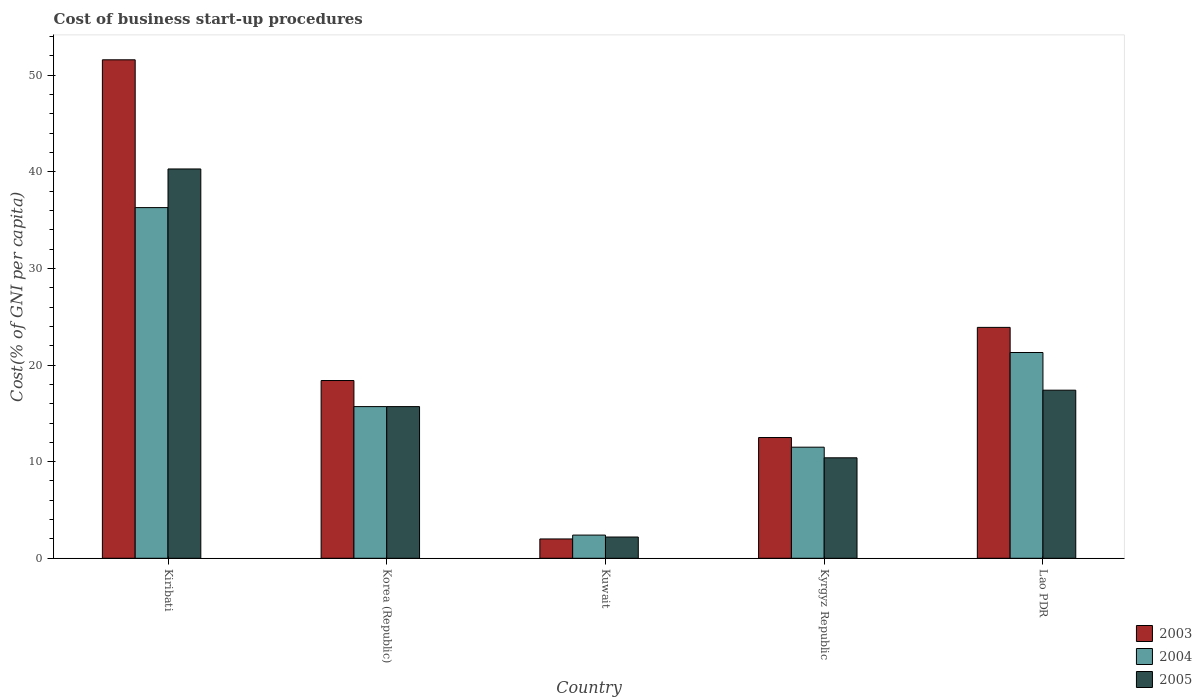How many different coloured bars are there?
Make the answer very short. 3. How many groups of bars are there?
Provide a short and direct response. 5. Are the number of bars per tick equal to the number of legend labels?
Keep it short and to the point. Yes. Are the number of bars on each tick of the X-axis equal?
Provide a succinct answer. Yes. How many bars are there on the 3rd tick from the right?
Your answer should be compact. 3. What is the label of the 4th group of bars from the left?
Your answer should be very brief. Kyrgyz Republic. In how many cases, is the number of bars for a given country not equal to the number of legend labels?
Your response must be concise. 0. What is the cost of business start-up procedures in 2004 in Korea (Republic)?
Make the answer very short. 15.7. Across all countries, what is the maximum cost of business start-up procedures in 2004?
Your response must be concise. 36.3. Across all countries, what is the minimum cost of business start-up procedures in 2003?
Provide a short and direct response. 2. In which country was the cost of business start-up procedures in 2003 maximum?
Keep it short and to the point. Kiribati. In which country was the cost of business start-up procedures in 2003 minimum?
Provide a short and direct response. Kuwait. What is the total cost of business start-up procedures in 2003 in the graph?
Give a very brief answer. 108.4. What is the difference between the cost of business start-up procedures in 2004 in Kuwait and that in Lao PDR?
Ensure brevity in your answer.  -18.9. What is the difference between the cost of business start-up procedures in 2005 in Kiribati and the cost of business start-up procedures in 2003 in Korea (Republic)?
Your response must be concise. 21.9. What is the average cost of business start-up procedures in 2003 per country?
Give a very brief answer. 21.68. What is the difference between the cost of business start-up procedures of/in 2003 and cost of business start-up procedures of/in 2004 in Kuwait?
Your answer should be compact. -0.4. What is the ratio of the cost of business start-up procedures in 2004 in Kyrgyz Republic to that in Lao PDR?
Ensure brevity in your answer.  0.54. Is the cost of business start-up procedures in 2005 in Kyrgyz Republic less than that in Lao PDR?
Your response must be concise. Yes. Is the difference between the cost of business start-up procedures in 2003 in Kiribati and Lao PDR greater than the difference between the cost of business start-up procedures in 2004 in Kiribati and Lao PDR?
Provide a succinct answer. Yes. What is the difference between the highest and the second highest cost of business start-up procedures in 2005?
Ensure brevity in your answer.  22.9. What is the difference between the highest and the lowest cost of business start-up procedures in 2004?
Provide a short and direct response. 33.9. How many bars are there?
Make the answer very short. 15. What is the difference between two consecutive major ticks on the Y-axis?
Provide a short and direct response. 10. Are the values on the major ticks of Y-axis written in scientific E-notation?
Offer a very short reply. No. Where does the legend appear in the graph?
Provide a succinct answer. Bottom right. How many legend labels are there?
Keep it short and to the point. 3. What is the title of the graph?
Ensure brevity in your answer.  Cost of business start-up procedures. What is the label or title of the X-axis?
Ensure brevity in your answer.  Country. What is the label or title of the Y-axis?
Offer a terse response. Cost(% of GNI per capita). What is the Cost(% of GNI per capita) of 2003 in Kiribati?
Your answer should be very brief. 51.6. What is the Cost(% of GNI per capita) in 2004 in Kiribati?
Give a very brief answer. 36.3. What is the Cost(% of GNI per capita) in 2005 in Kiribati?
Offer a very short reply. 40.3. What is the Cost(% of GNI per capita) in 2003 in Kuwait?
Provide a short and direct response. 2. What is the Cost(% of GNI per capita) of 2005 in Kuwait?
Offer a very short reply. 2.2. What is the Cost(% of GNI per capita) in 2003 in Lao PDR?
Give a very brief answer. 23.9. What is the Cost(% of GNI per capita) of 2004 in Lao PDR?
Provide a short and direct response. 21.3. What is the Cost(% of GNI per capita) of 2005 in Lao PDR?
Your answer should be very brief. 17.4. Across all countries, what is the maximum Cost(% of GNI per capita) in 2003?
Keep it short and to the point. 51.6. Across all countries, what is the maximum Cost(% of GNI per capita) of 2004?
Ensure brevity in your answer.  36.3. Across all countries, what is the maximum Cost(% of GNI per capita) in 2005?
Your answer should be compact. 40.3. Across all countries, what is the minimum Cost(% of GNI per capita) of 2003?
Make the answer very short. 2. Across all countries, what is the minimum Cost(% of GNI per capita) of 2004?
Offer a very short reply. 2.4. What is the total Cost(% of GNI per capita) of 2003 in the graph?
Provide a succinct answer. 108.4. What is the total Cost(% of GNI per capita) of 2004 in the graph?
Offer a terse response. 87.2. What is the difference between the Cost(% of GNI per capita) in 2003 in Kiribati and that in Korea (Republic)?
Make the answer very short. 33.2. What is the difference between the Cost(% of GNI per capita) of 2004 in Kiribati and that in Korea (Republic)?
Provide a succinct answer. 20.6. What is the difference between the Cost(% of GNI per capita) in 2005 in Kiribati and that in Korea (Republic)?
Your response must be concise. 24.6. What is the difference between the Cost(% of GNI per capita) of 2003 in Kiribati and that in Kuwait?
Your answer should be compact. 49.6. What is the difference between the Cost(% of GNI per capita) in 2004 in Kiribati and that in Kuwait?
Give a very brief answer. 33.9. What is the difference between the Cost(% of GNI per capita) of 2005 in Kiribati and that in Kuwait?
Provide a succinct answer. 38.1. What is the difference between the Cost(% of GNI per capita) of 2003 in Kiribati and that in Kyrgyz Republic?
Ensure brevity in your answer.  39.1. What is the difference between the Cost(% of GNI per capita) in 2004 in Kiribati and that in Kyrgyz Republic?
Make the answer very short. 24.8. What is the difference between the Cost(% of GNI per capita) of 2005 in Kiribati and that in Kyrgyz Republic?
Ensure brevity in your answer.  29.9. What is the difference between the Cost(% of GNI per capita) of 2003 in Kiribati and that in Lao PDR?
Make the answer very short. 27.7. What is the difference between the Cost(% of GNI per capita) of 2005 in Kiribati and that in Lao PDR?
Your response must be concise. 22.9. What is the difference between the Cost(% of GNI per capita) of 2003 in Korea (Republic) and that in Kuwait?
Ensure brevity in your answer.  16.4. What is the difference between the Cost(% of GNI per capita) of 2004 in Korea (Republic) and that in Kyrgyz Republic?
Provide a short and direct response. 4.2. What is the difference between the Cost(% of GNI per capita) of 2005 in Korea (Republic) and that in Kyrgyz Republic?
Your response must be concise. 5.3. What is the difference between the Cost(% of GNI per capita) in 2003 in Kuwait and that in Kyrgyz Republic?
Make the answer very short. -10.5. What is the difference between the Cost(% of GNI per capita) in 2003 in Kuwait and that in Lao PDR?
Make the answer very short. -21.9. What is the difference between the Cost(% of GNI per capita) in 2004 in Kuwait and that in Lao PDR?
Offer a terse response. -18.9. What is the difference between the Cost(% of GNI per capita) in 2005 in Kuwait and that in Lao PDR?
Make the answer very short. -15.2. What is the difference between the Cost(% of GNI per capita) in 2005 in Kyrgyz Republic and that in Lao PDR?
Offer a terse response. -7. What is the difference between the Cost(% of GNI per capita) of 2003 in Kiribati and the Cost(% of GNI per capita) of 2004 in Korea (Republic)?
Provide a short and direct response. 35.9. What is the difference between the Cost(% of GNI per capita) in 2003 in Kiribati and the Cost(% of GNI per capita) in 2005 in Korea (Republic)?
Provide a succinct answer. 35.9. What is the difference between the Cost(% of GNI per capita) in 2004 in Kiribati and the Cost(% of GNI per capita) in 2005 in Korea (Republic)?
Your answer should be compact. 20.6. What is the difference between the Cost(% of GNI per capita) of 2003 in Kiribati and the Cost(% of GNI per capita) of 2004 in Kuwait?
Offer a terse response. 49.2. What is the difference between the Cost(% of GNI per capita) of 2003 in Kiribati and the Cost(% of GNI per capita) of 2005 in Kuwait?
Your response must be concise. 49.4. What is the difference between the Cost(% of GNI per capita) in 2004 in Kiribati and the Cost(% of GNI per capita) in 2005 in Kuwait?
Keep it short and to the point. 34.1. What is the difference between the Cost(% of GNI per capita) of 2003 in Kiribati and the Cost(% of GNI per capita) of 2004 in Kyrgyz Republic?
Your answer should be very brief. 40.1. What is the difference between the Cost(% of GNI per capita) of 2003 in Kiribati and the Cost(% of GNI per capita) of 2005 in Kyrgyz Republic?
Keep it short and to the point. 41.2. What is the difference between the Cost(% of GNI per capita) in 2004 in Kiribati and the Cost(% of GNI per capita) in 2005 in Kyrgyz Republic?
Provide a short and direct response. 25.9. What is the difference between the Cost(% of GNI per capita) in 2003 in Kiribati and the Cost(% of GNI per capita) in 2004 in Lao PDR?
Give a very brief answer. 30.3. What is the difference between the Cost(% of GNI per capita) of 2003 in Kiribati and the Cost(% of GNI per capita) of 2005 in Lao PDR?
Offer a very short reply. 34.2. What is the difference between the Cost(% of GNI per capita) of 2003 in Korea (Republic) and the Cost(% of GNI per capita) of 2004 in Kuwait?
Ensure brevity in your answer.  16. What is the difference between the Cost(% of GNI per capita) of 2003 in Korea (Republic) and the Cost(% of GNI per capita) of 2005 in Kuwait?
Make the answer very short. 16.2. What is the difference between the Cost(% of GNI per capita) in 2004 in Korea (Republic) and the Cost(% of GNI per capita) in 2005 in Kyrgyz Republic?
Offer a very short reply. 5.3. What is the difference between the Cost(% of GNI per capita) in 2003 in Korea (Republic) and the Cost(% of GNI per capita) in 2005 in Lao PDR?
Ensure brevity in your answer.  1. What is the difference between the Cost(% of GNI per capita) of 2003 in Kuwait and the Cost(% of GNI per capita) of 2005 in Kyrgyz Republic?
Make the answer very short. -8.4. What is the difference between the Cost(% of GNI per capita) in 2004 in Kuwait and the Cost(% of GNI per capita) in 2005 in Kyrgyz Republic?
Keep it short and to the point. -8. What is the difference between the Cost(% of GNI per capita) of 2003 in Kuwait and the Cost(% of GNI per capita) of 2004 in Lao PDR?
Ensure brevity in your answer.  -19.3. What is the difference between the Cost(% of GNI per capita) in 2003 in Kuwait and the Cost(% of GNI per capita) in 2005 in Lao PDR?
Ensure brevity in your answer.  -15.4. What is the difference between the Cost(% of GNI per capita) of 2003 in Kyrgyz Republic and the Cost(% of GNI per capita) of 2004 in Lao PDR?
Give a very brief answer. -8.8. What is the difference between the Cost(% of GNI per capita) of 2004 in Kyrgyz Republic and the Cost(% of GNI per capita) of 2005 in Lao PDR?
Provide a short and direct response. -5.9. What is the average Cost(% of GNI per capita) in 2003 per country?
Offer a terse response. 21.68. What is the average Cost(% of GNI per capita) of 2004 per country?
Give a very brief answer. 17.44. What is the average Cost(% of GNI per capita) of 2005 per country?
Keep it short and to the point. 17.2. What is the difference between the Cost(% of GNI per capita) in 2003 and Cost(% of GNI per capita) in 2004 in Kiribati?
Offer a very short reply. 15.3. What is the difference between the Cost(% of GNI per capita) in 2004 and Cost(% of GNI per capita) in 2005 in Kiribati?
Your answer should be very brief. -4. What is the difference between the Cost(% of GNI per capita) of 2003 and Cost(% of GNI per capita) of 2004 in Korea (Republic)?
Keep it short and to the point. 2.7. What is the difference between the Cost(% of GNI per capita) in 2003 and Cost(% of GNI per capita) in 2005 in Korea (Republic)?
Keep it short and to the point. 2.7. What is the difference between the Cost(% of GNI per capita) of 2003 and Cost(% of GNI per capita) of 2004 in Kuwait?
Ensure brevity in your answer.  -0.4. What is the difference between the Cost(% of GNI per capita) of 2004 and Cost(% of GNI per capita) of 2005 in Kuwait?
Offer a very short reply. 0.2. What is the difference between the Cost(% of GNI per capita) in 2003 and Cost(% of GNI per capita) in 2005 in Kyrgyz Republic?
Offer a terse response. 2.1. What is the difference between the Cost(% of GNI per capita) in 2004 and Cost(% of GNI per capita) in 2005 in Kyrgyz Republic?
Provide a short and direct response. 1.1. What is the difference between the Cost(% of GNI per capita) in 2003 and Cost(% of GNI per capita) in 2004 in Lao PDR?
Offer a very short reply. 2.6. What is the ratio of the Cost(% of GNI per capita) of 2003 in Kiribati to that in Korea (Republic)?
Offer a terse response. 2.8. What is the ratio of the Cost(% of GNI per capita) in 2004 in Kiribati to that in Korea (Republic)?
Provide a succinct answer. 2.31. What is the ratio of the Cost(% of GNI per capita) in 2005 in Kiribati to that in Korea (Republic)?
Offer a very short reply. 2.57. What is the ratio of the Cost(% of GNI per capita) of 2003 in Kiribati to that in Kuwait?
Provide a short and direct response. 25.8. What is the ratio of the Cost(% of GNI per capita) of 2004 in Kiribati to that in Kuwait?
Your response must be concise. 15.12. What is the ratio of the Cost(% of GNI per capita) of 2005 in Kiribati to that in Kuwait?
Keep it short and to the point. 18.32. What is the ratio of the Cost(% of GNI per capita) in 2003 in Kiribati to that in Kyrgyz Republic?
Make the answer very short. 4.13. What is the ratio of the Cost(% of GNI per capita) of 2004 in Kiribati to that in Kyrgyz Republic?
Offer a terse response. 3.16. What is the ratio of the Cost(% of GNI per capita) in 2005 in Kiribati to that in Kyrgyz Republic?
Make the answer very short. 3.88. What is the ratio of the Cost(% of GNI per capita) in 2003 in Kiribati to that in Lao PDR?
Your answer should be compact. 2.16. What is the ratio of the Cost(% of GNI per capita) in 2004 in Kiribati to that in Lao PDR?
Give a very brief answer. 1.7. What is the ratio of the Cost(% of GNI per capita) of 2005 in Kiribati to that in Lao PDR?
Offer a very short reply. 2.32. What is the ratio of the Cost(% of GNI per capita) in 2003 in Korea (Republic) to that in Kuwait?
Give a very brief answer. 9.2. What is the ratio of the Cost(% of GNI per capita) of 2004 in Korea (Republic) to that in Kuwait?
Ensure brevity in your answer.  6.54. What is the ratio of the Cost(% of GNI per capita) in 2005 in Korea (Republic) to that in Kuwait?
Your response must be concise. 7.14. What is the ratio of the Cost(% of GNI per capita) in 2003 in Korea (Republic) to that in Kyrgyz Republic?
Keep it short and to the point. 1.47. What is the ratio of the Cost(% of GNI per capita) of 2004 in Korea (Republic) to that in Kyrgyz Republic?
Your response must be concise. 1.37. What is the ratio of the Cost(% of GNI per capita) of 2005 in Korea (Republic) to that in Kyrgyz Republic?
Your answer should be compact. 1.51. What is the ratio of the Cost(% of GNI per capita) in 2003 in Korea (Republic) to that in Lao PDR?
Offer a very short reply. 0.77. What is the ratio of the Cost(% of GNI per capita) in 2004 in Korea (Republic) to that in Lao PDR?
Your answer should be compact. 0.74. What is the ratio of the Cost(% of GNI per capita) in 2005 in Korea (Republic) to that in Lao PDR?
Offer a terse response. 0.9. What is the ratio of the Cost(% of GNI per capita) of 2003 in Kuwait to that in Kyrgyz Republic?
Offer a terse response. 0.16. What is the ratio of the Cost(% of GNI per capita) of 2004 in Kuwait to that in Kyrgyz Republic?
Offer a terse response. 0.21. What is the ratio of the Cost(% of GNI per capita) in 2005 in Kuwait to that in Kyrgyz Republic?
Ensure brevity in your answer.  0.21. What is the ratio of the Cost(% of GNI per capita) of 2003 in Kuwait to that in Lao PDR?
Provide a short and direct response. 0.08. What is the ratio of the Cost(% of GNI per capita) of 2004 in Kuwait to that in Lao PDR?
Provide a succinct answer. 0.11. What is the ratio of the Cost(% of GNI per capita) of 2005 in Kuwait to that in Lao PDR?
Your response must be concise. 0.13. What is the ratio of the Cost(% of GNI per capita) in 2003 in Kyrgyz Republic to that in Lao PDR?
Your response must be concise. 0.52. What is the ratio of the Cost(% of GNI per capita) in 2004 in Kyrgyz Republic to that in Lao PDR?
Your answer should be very brief. 0.54. What is the ratio of the Cost(% of GNI per capita) of 2005 in Kyrgyz Republic to that in Lao PDR?
Ensure brevity in your answer.  0.6. What is the difference between the highest and the second highest Cost(% of GNI per capita) of 2003?
Your answer should be very brief. 27.7. What is the difference between the highest and the second highest Cost(% of GNI per capita) in 2004?
Offer a terse response. 15. What is the difference between the highest and the second highest Cost(% of GNI per capita) of 2005?
Keep it short and to the point. 22.9. What is the difference between the highest and the lowest Cost(% of GNI per capita) in 2003?
Make the answer very short. 49.6. What is the difference between the highest and the lowest Cost(% of GNI per capita) of 2004?
Provide a succinct answer. 33.9. What is the difference between the highest and the lowest Cost(% of GNI per capita) of 2005?
Give a very brief answer. 38.1. 